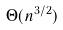<formula> <loc_0><loc_0><loc_500><loc_500>\Theta ( n ^ { 3 / 2 } )</formula> 